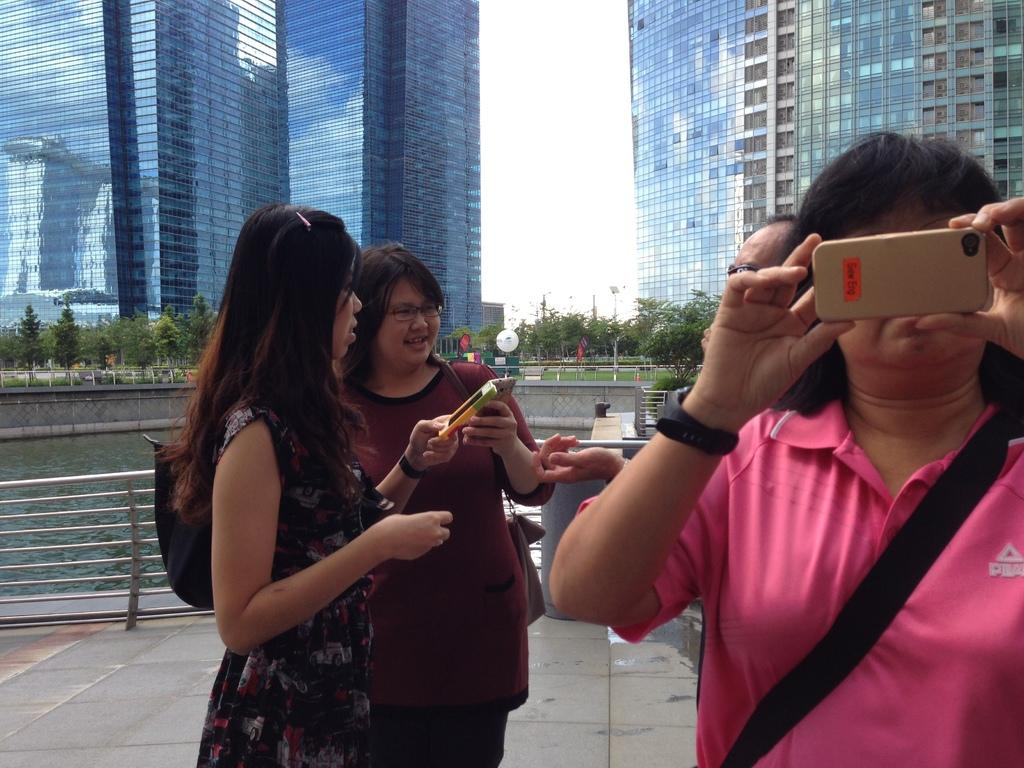How many people are in the image? There are three lady persons in the image. What are the lady persons holding in their hands? Each lady person is holding a mobile phone in their hand. What can be seen in the background of the image? There are buildings in the background of the image. What type of pizzas are being served to the lady persons in the image? There are no pizzas present in the image; the lady persons are holding mobile phones. 